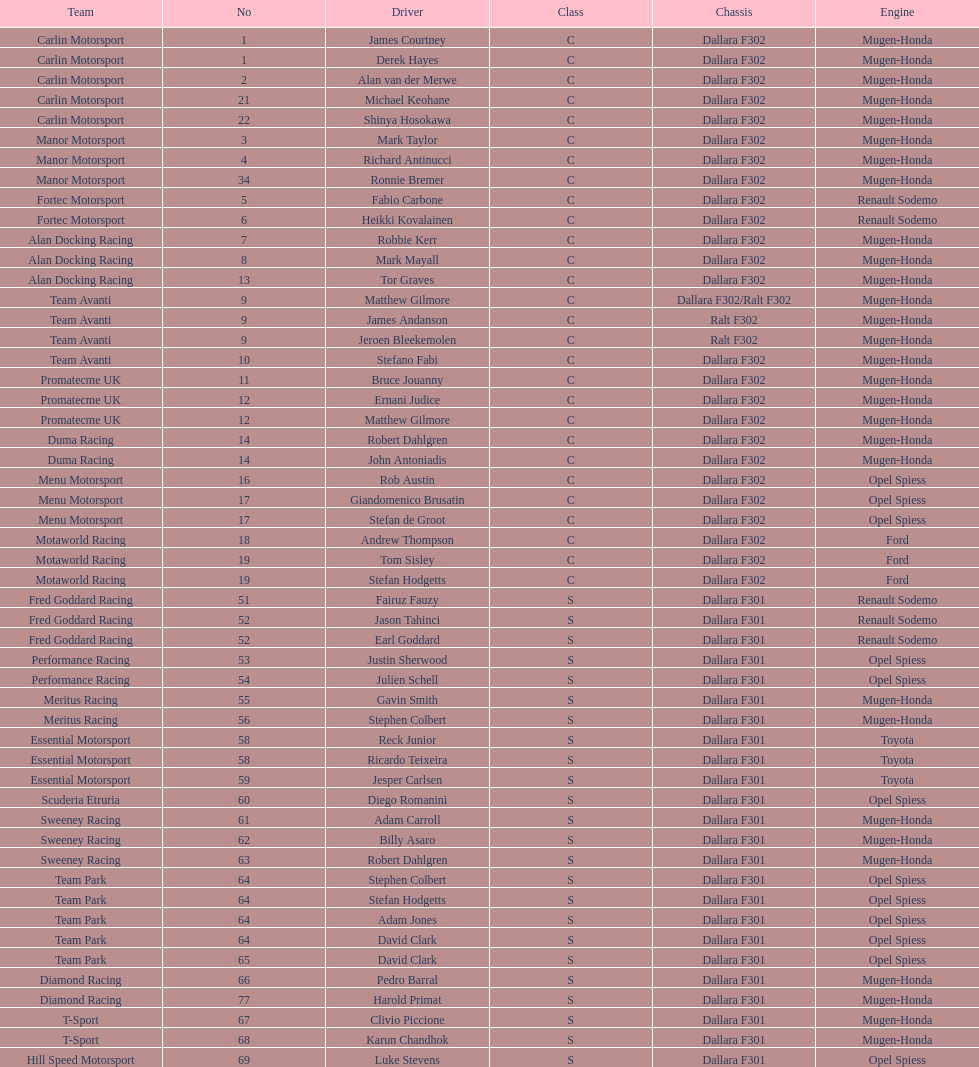How many teams had drivers exclusively from one country? 4. 